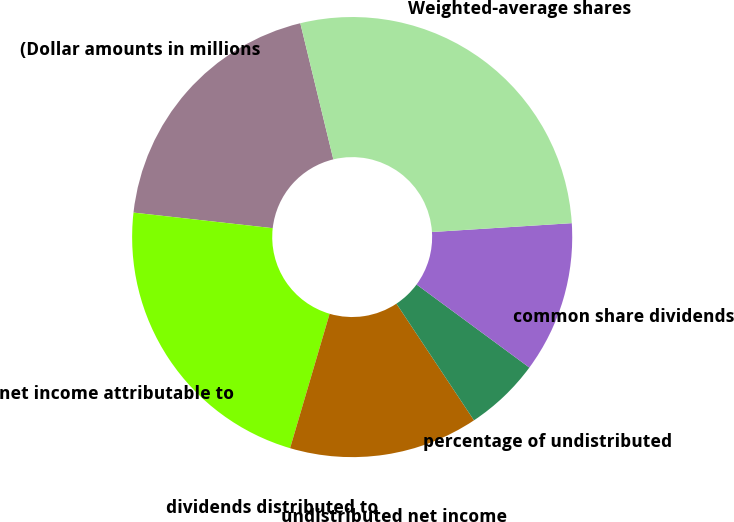<chart> <loc_0><loc_0><loc_500><loc_500><pie_chart><fcel>(Dollar amounts in millions<fcel>net income attributable to<fcel>dividends distributed to<fcel>undistributed net income<fcel>percentage of undistributed<fcel>common share dividends<fcel>Weighted-average shares<nl><fcel>19.44%<fcel>22.22%<fcel>0.0%<fcel>13.89%<fcel>5.56%<fcel>11.11%<fcel>27.78%<nl></chart> 